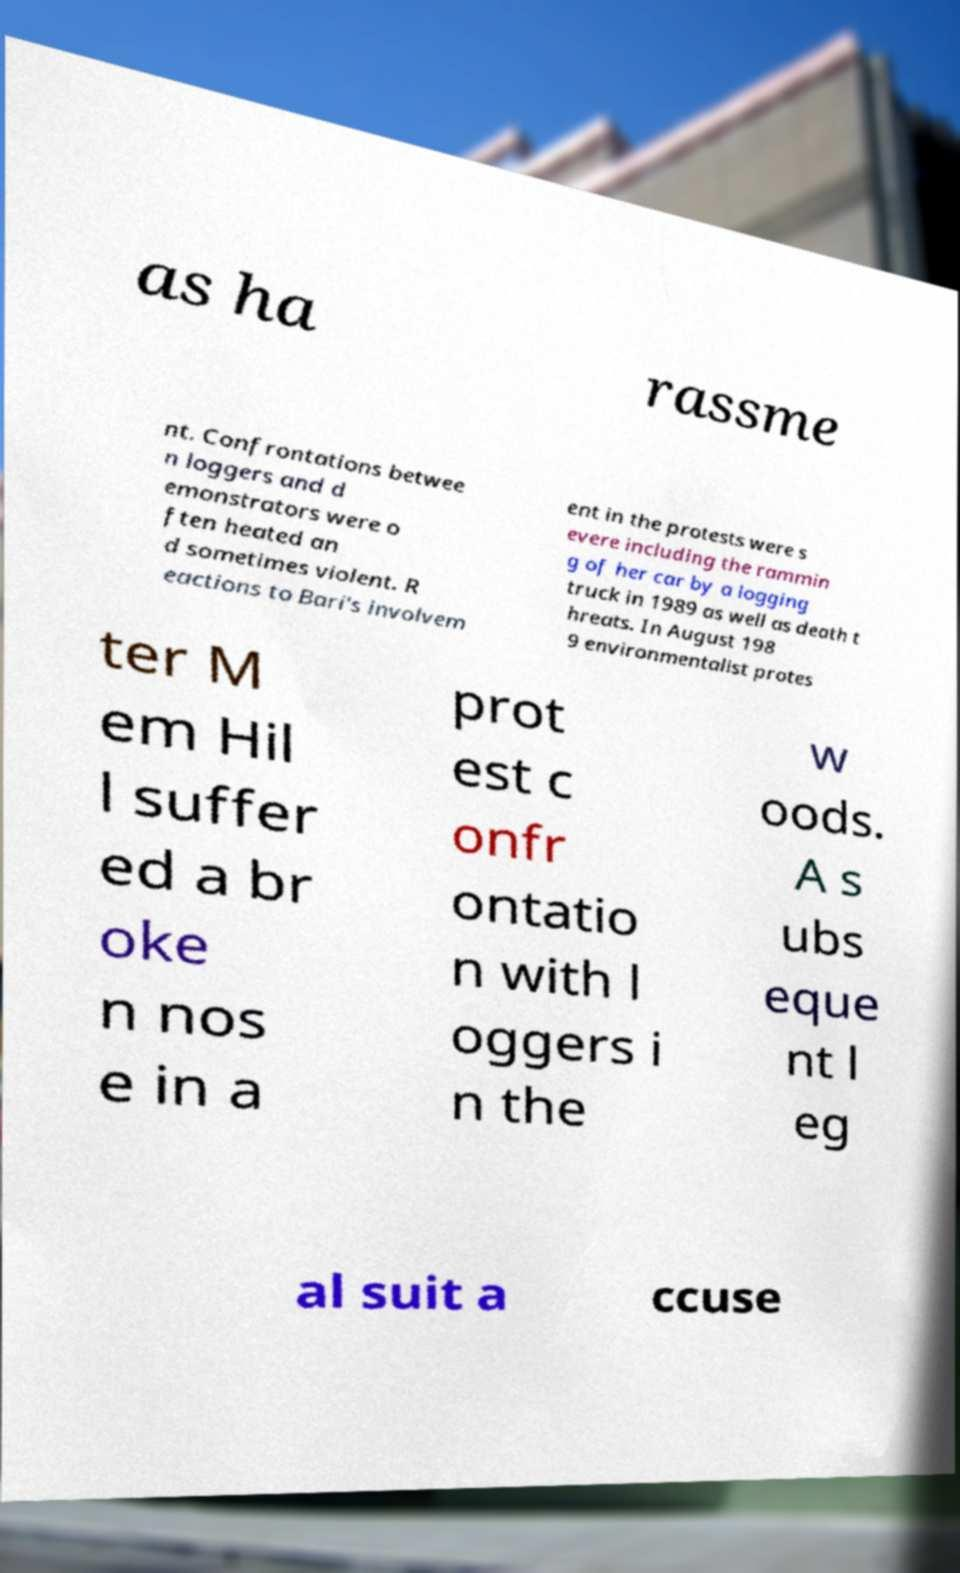Can you read and provide the text displayed in the image?This photo seems to have some interesting text. Can you extract and type it out for me? as ha rassme nt. Confrontations betwee n loggers and d emonstrators were o ften heated an d sometimes violent. R eactions to Bari's involvem ent in the protests were s evere including the rammin g of her car by a logging truck in 1989 as well as death t hreats. In August 198 9 environmentalist protes ter M em Hil l suffer ed a br oke n nos e in a prot est c onfr ontatio n with l oggers i n the w oods. A s ubs eque nt l eg al suit a ccuse 